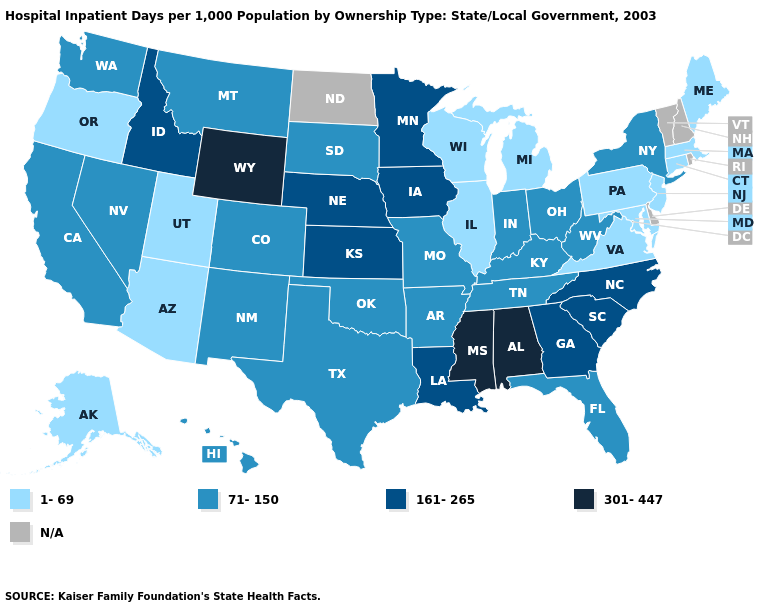What is the lowest value in the West?
Answer briefly. 1-69. What is the value of Connecticut?
Give a very brief answer. 1-69. What is the value of Illinois?
Short answer required. 1-69. Name the states that have a value in the range N/A?
Concise answer only. Delaware, New Hampshire, North Dakota, Rhode Island, Vermont. What is the lowest value in the USA?
Quick response, please. 1-69. What is the value of Texas?
Give a very brief answer. 71-150. Which states have the lowest value in the USA?
Answer briefly. Alaska, Arizona, Connecticut, Illinois, Maine, Maryland, Massachusetts, Michigan, New Jersey, Oregon, Pennsylvania, Utah, Virginia, Wisconsin. What is the highest value in the South ?
Keep it brief. 301-447. Which states have the lowest value in the West?
Concise answer only. Alaska, Arizona, Oregon, Utah. What is the lowest value in states that border Arkansas?
Give a very brief answer. 71-150. Name the states that have a value in the range 1-69?
Short answer required. Alaska, Arizona, Connecticut, Illinois, Maine, Maryland, Massachusetts, Michigan, New Jersey, Oregon, Pennsylvania, Utah, Virginia, Wisconsin. What is the value of Idaho?
Write a very short answer. 161-265. 